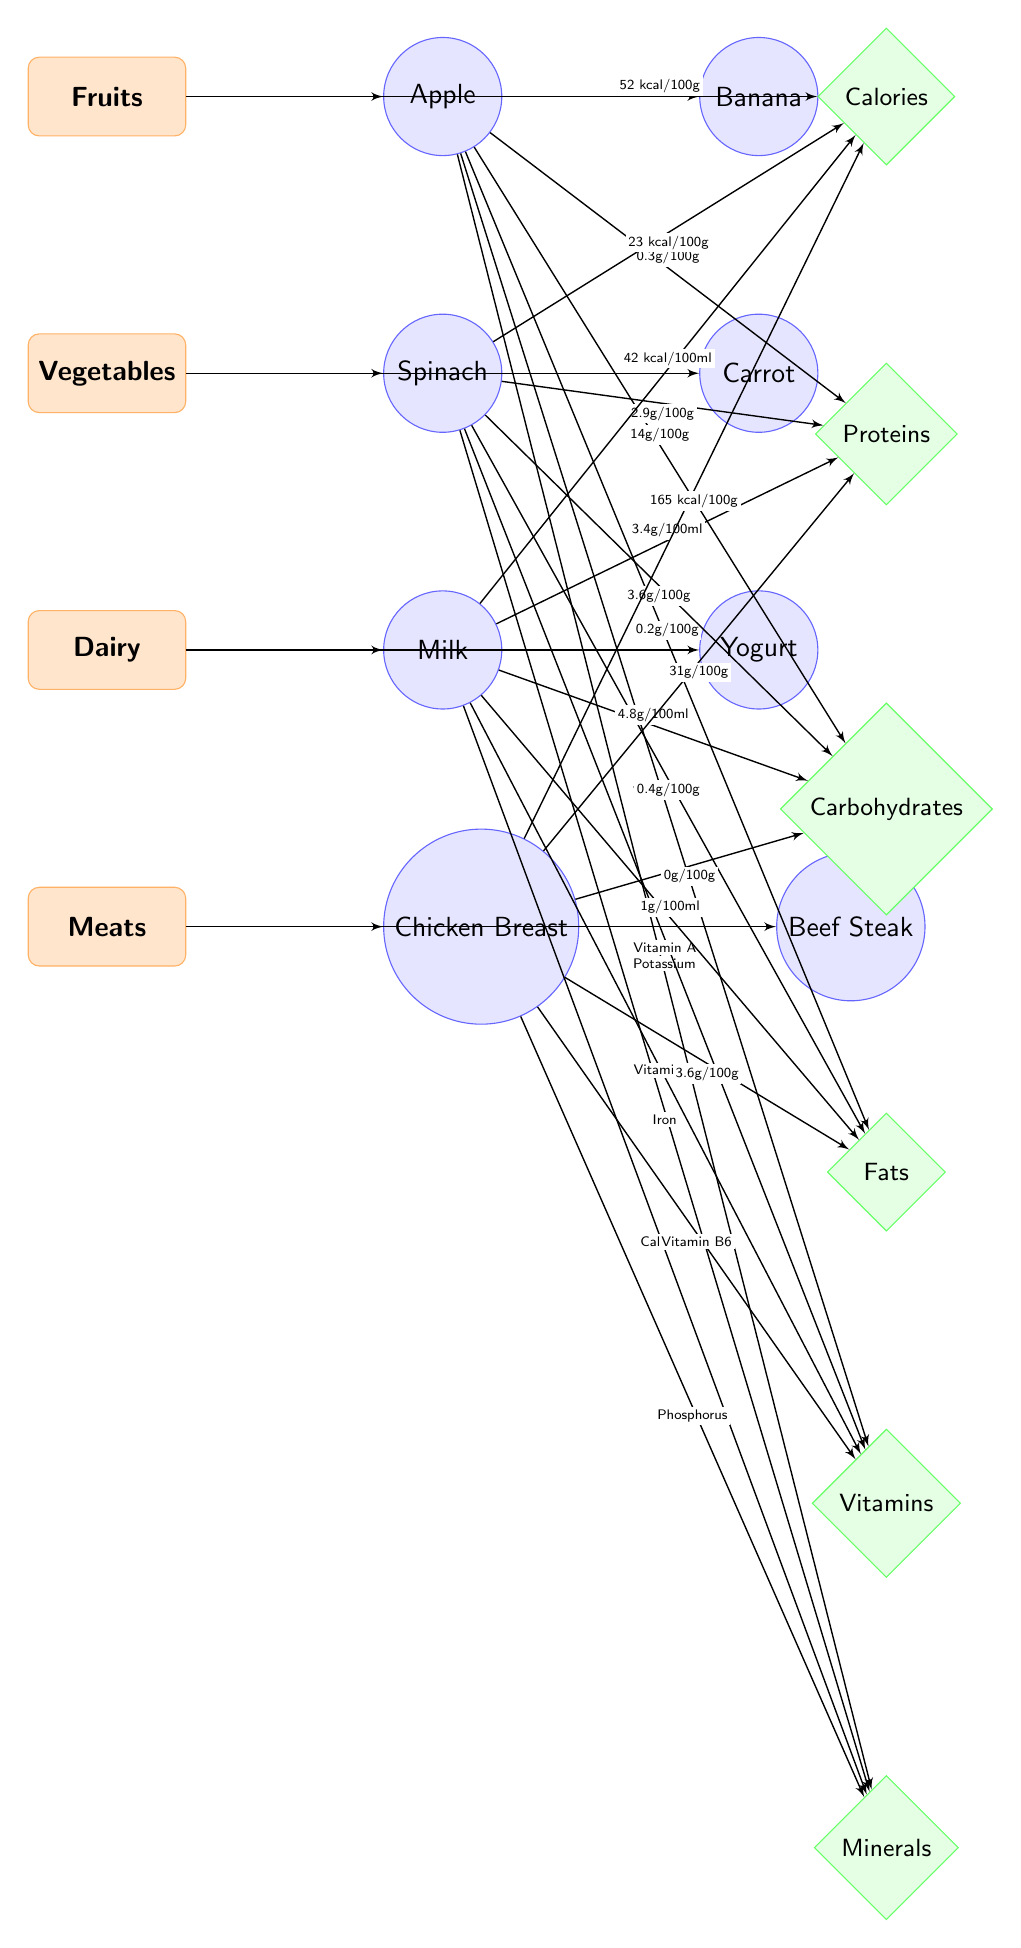What are the calories in an apple? The diagram shows a connection from the apple node to the calories nutrient node, which states "52 kcal/100g," indicating the caloric content.
Answer: 52 kcal/100g What type of vitamin is found in spinach? The spinach node is connected to the vitamins nutrient node, which lists "Vitamin A," indicating the specific vitamin present in spinach.
Answer: Vitamin A How many types of nutrient categories are shown? There are four distinct categories of nutrients listed in the diagram: Fruits, Vegetables, Dairy, and Meats, which can be counted directly.
Answer: 4 Which food has the highest protein content? The chicken node connects to the proteins nutrient node, showing "31g/100g," while other foods show lower protein contents upon inspection, making it the highest.
Answer: Chicken Breast How many grams of carbohydrates are in a banana? The diagram doesn’t provide specific carb information for the banana, suggesting either it's not included or displayed; thus, to find the answer, we confirm that data is not shown.
Answer: Not shown in diagram What is the primary mineral found in chicken? The chicken node connects to the minerals nutrient node, indicating "Phosphorus" as the mineral found in chicken, providing a clear relationship to identify the mineral.
Answer: Phosphorus Which food has the lowest caloric content? By comparing the caloric connections, spinach shows "23 kcal/100g," which is lower than the other foods listed, thus making it the lowest in calories.
Answer: Spinach What is the carbohydrate content in milk? Directly connected from the milk node to the carbs nutrient node, the diagram states "4.8g/100ml," providing the specific carbohydrate information for milk.
Answer: 4.8g/100ml Which food is rich in calcium? The milk node shows a connection to the minerals nutrient node, specifically stating "Calcium," indicating that milk is a source rich in this mineral.
Answer: Milk 